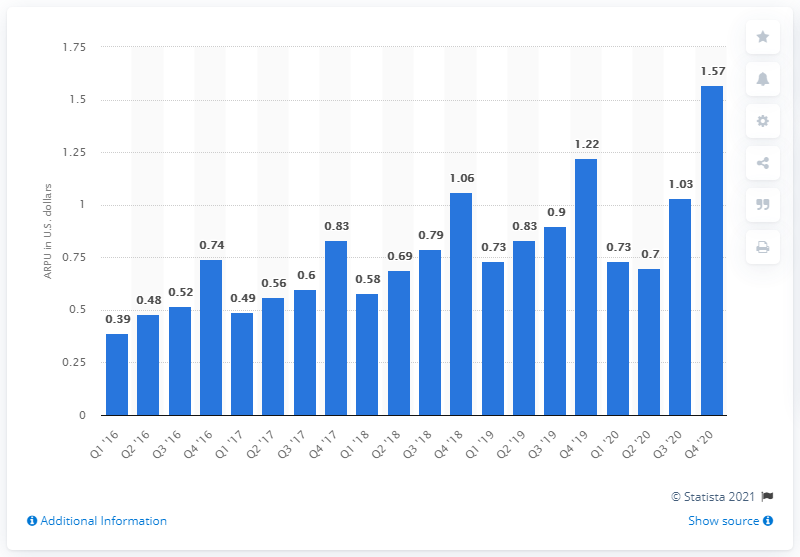Mention a couple of crucial points in this snapshot. Pinterest's ARPU in the previous quarter was 1.03. In the fourth quarter of 2020, Pinterest's ARPU (average revenue per user) was 1.57. 